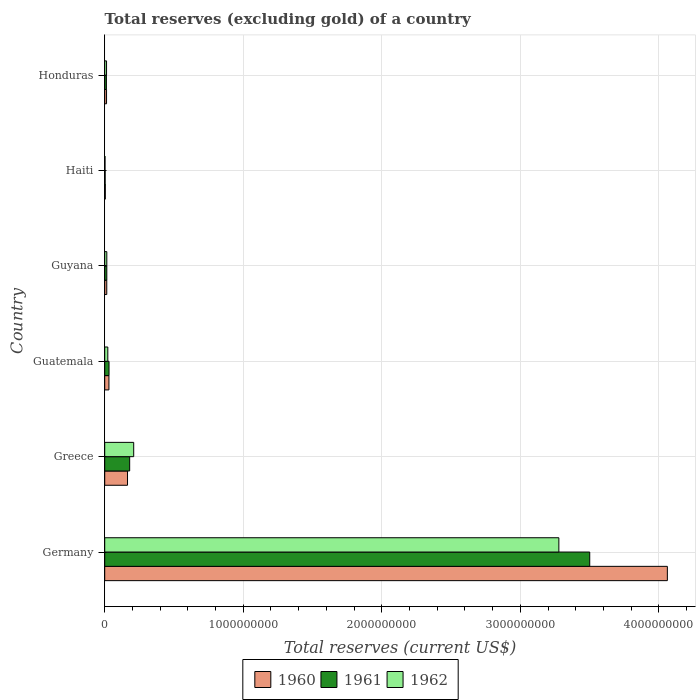How many bars are there on the 1st tick from the top?
Offer a terse response. 3. What is the label of the 2nd group of bars from the top?
Ensure brevity in your answer.  Haiti. What is the total reserves (excluding gold) in 1962 in Haiti?
Provide a succinct answer. 2.20e+06. Across all countries, what is the maximum total reserves (excluding gold) in 1962?
Offer a very short reply. 3.28e+09. Across all countries, what is the minimum total reserves (excluding gold) in 1962?
Provide a short and direct response. 2.20e+06. In which country was the total reserves (excluding gold) in 1961 maximum?
Make the answer very short. Germany. In which country was the total reserves (excluding gold) in 1962 minimum?
Your response must be concise. Haiti. What is the total total reserves (excluding gold) in 1961 in the graph?
Provide a short and direct response. 3.74e+09. What is the difference between the total reserves (excluding gold) in 1962 in Haiti and that in Honduras?
Provide a succinct answer. -1.10e+07. What is the difference between the total reserves (excluding gold) in 1960 in Guyana and the total reserves (excluding gold) in 1961 in Honduras?
Your response must be concise. 2.52e+06. What is the average total reserves (excluding gold) in 1960 per country?
Make the answer very short. 7.15e+08. What is the difference between the total reserves (excluding gold) in 1961 and total reserves (excluding gold) in 1960 in Honduras?
Make the answer very short. -9.90e+05. What is the ratio of the total reserves (excluding gold) in 1961 in Greece to that in Guyana?
Your answer should be very brief. 11.94. Is the total reserves (excluding gold) in 1961 in Germany less than that in Guatemala?
Provide a short and direct response. No. What is the difference between the highest and the second highest total reserves (excluding gold) in 1960?
Provide a succinct answer. 3.90e+09. What is the difference between the highest and the lowest total reserves (excluding gold) in 1961?
Make the answer very short. 3.50e+09. In how many countries, is the total reserves (excluding gold) in 1960 greater than the average total reserves (excluding gold) in 1960 taken over all countries?
Give a very brief answer. 1. What does the 1st bar from the top in Greece represents?
Provide a succinct answer. 1962. What does the 1st bar from the bottom in Greece represents?
Provide a short and direct response. 1960. Are all the bars in the graph horizontal?
Your answer should be very brief. Yes. What is the difference between two consecutive major ticks on the X-axis?
Offer a terse response. 1.00e+09. Are the values on the major ticks of X-axis written in scientific E-notation?
Provide a succinct answer. No. Does the graph contain grids?
Offer a terse response. Yes. Where does the legend appear in the graph?
Provide a short and direct response. Bottom center. How many legend labels are there?
Provide a short and direct response. 3. What is the title of the graph?
Provide a succinct answer. Total reserves (excluding gold) of a country. What is the label or title of the X-axis?
Offer a very short reply. Total reserves (current US$). What is the Total reserves (current US$) of 1960 in Germany?
Your answer should be compact. 4.06e+09. What is the Total reserves (current US$) in 1961 in Germany?
Offer a very short reply. 3.50e+09. What is the Total reserves (current US$) of 1962 in Germany?
Offer a terse response. 3.28e+09. What is the Total reserves (current US$) of 1960 in Greece?
Make the answer very short. 1.65e+08. What is the Total reserves (current US$) of 1961 in Greece?
Offer a terse response. 1.80e+08. What is the Total reserves (current US$) of 1962 in Greece?
Provide a succinct answer. 2.09e+08. What is the Total reserves (current US$) in 1960 in Guatemala?
Provide a short and direct response. 3.05e+07. What is the Total reserves (current US$) of 1961 in Guatemala?
Offer a terse response. 3.12e+07. What is the Total reserves (current US$) in 1962 in Guatemala?
Make the answer very short. 2.23e+07. What is the Total reserves (current US$) of 1960 in Guyana?
Offer a terse response. 1.47e+07. What is the Total reserves (current US$) in 1961 in Guyana?
Your answer should be very brief. 1.51e+07. What is the Total reserves (current US$) of 1962 in Guyana?
Provide a succinct answer. 1.51e+07. What is the Total reserves (current US$) of 1960 in Haiti?
Your answer should be compact. 4.30e+06. What is the Total reserves (current US$) of 1962 in Haiti?
Your answer should be compact. 2.20e+06. What is the Total reserves (current US$) in 1960 in Honduras?
Make the answer very short. 1.32e+07. What is the Total reserves (current US$) of 1961 in Honduras?
Offer a terse response. 1.22e+07. What is the Total reserves (current US$) in 1962 in Honduras?
Offer a terse response. 1.32e+07. Across all countries, what is the maximum Total reserves (current US$) of 1960?
Your answer should be compact. 4.06e+09. Across all countries, what is the maximum Total reserves (current US$) of 1961?
Make the answer very short. 3.50e+09. Across all countries, what is the maximum Total reserves (current US$) in 1962?
Keep it short and to the point. 3.28e+09. Across all countries, what is the minimum Total reserves (current US$) of 1960?
Give a very brief answer. 4.30e+06. Across all countries, what is the minimum Total reserves (current US$) of 1961?
Provide a short and direct response. 3.00e+06. Across all countries, what is the minimum Total reserves (current US$) in 1962?
Offer a terse response. 2.20e+06. What is the total Total reserves (current US$) in 1960 in the graph?
Make the answer very short. 4.29e+09. What is the total Total reserves (current US$) in 1961 in the graph?
Make the answer very short. 3.74e+09. What is the total Total reserves (current US$) of 1962 in the graph?
Make the answer very short. 3.54e+09. What is the difference between the Total reserves (current US$) of 1960 in Germany and that in Greece?
Your answer should be compact. 3.90e+09. What is the difference between the Total reserves (current US$) of 1961 in Germany and that in Greece?
Make the answer very short. 3.32e+09. What is the difference between the Total reserves (current US$) of 1962 in Germany and that in Greece?
Provide a succinct answer. 3.07e+09. What is the difference between the Total reserves (current US$) in 1960 in Germany and that in Guatemala?
Ensure brevity in your answer.  4.03e+09. What is the difference between the Total reserves (current US$) of 1961 in Germany and that in Guatemala?
Offer a very short reply. 3.47e+09. What is the difference between the Total reserves (current US$) in 1962 in Germany and that in Guatemala?
Make the answer very short. 3.26e+09. What is the difference between the Total reserves (current US$) in 1960 in Germany and that in Guyana?
Provide a short and direct response. 4.05e+09. What is the difference between the Total reserves (current US$) in 1961 in Germany and that in Guyana?
Your answer should be very brief. 3.49e+09. What is the difference between the Total reserves (current US$) of 1962 in Germany and that in Guyana?
Your answer should be compact. 3.26e+09. What is the difference between the Total reserves (current US$) of 1960 in Germany and that in Haiti?
Ensure brevity in your answer.  4.06e+09. What is the difference between the Total reserves (current US$) of 1961 in Germany and that in Haiti?
Your answer should be very brief. 3.50e+09. What is the difference between the Total reserves (current US$) of 1962 in Germany and that in Haiti?
Provide a short and direct response. 3.28e+09. What is the difference between the Total reserves (current US$) of 1960 in Germany and that in Honduras?
Your answer should be compact. 4.05e+09. What is the difference between the Total reserves (current US$) of 1961 in Germany and that in Honduras?
Your answer should be very brief. 3.49e+09. What is the difference between the Total reserves (current US$) in 1962 in Germany and that in Honduras?
Keep it short and to the point. 3.27e+09. What is the difference between the Total reserves (current US$) of 1960 in Greece and that in Guatemala?
Make the answer very short. 1.34e+08. What is the difference between the Total reserves (current US$) of 1961 in Greece and that in Guatemala?
Offer a very short reply. 1.49e+08. What is the difference between the Total reserves (current US$) in 1962 in Greece and that in Guatemala?
Provide a succinct answer. 1.87e+08. What is the difference between the Total reserves (current US$) of 1960 in Greece and that in Guyana?
Your answer should be compact. 1.50e+08. What is the difference between the Total reserves (current US$) of 1961 in Greece and that in Guyana?
Make the answer very short. 1.65e+08. What is the difference between the Total reserves (current US$) of 1962 in Greece and that in Guyana?
Provide a succinct answer. 1.94e+08. What is the difference between the Total reserves (current US$) in 1960 in Greece and that in Haiti?
Keep it short and to the point. 1.60e+08. What is the difference between the Total reserves (current US$) in 1961 in Greece and that in Haiti?
Ensure brevity in your answer.  1.77e+08. What is the difference between the Total reserves (current US$) of 1962 in Greece and that in Haiti?
Ensure brevity in your answer.  2.07e+08. What is the difference between the Total reserves (current US$) in 1960 in Greece and that in Honduras?
Offer a terse response. 1.51e+08. What is the difference between the Total reserves (current US$) of 1961 in Greece and that in Honduras?
Provide a short and direct response. 1.68e+08. What is the difference between the Total reserves (current US$) in 1962 in Greece and that in Honduras?
Your response must be concise. 1.96e+08. What is the difference between the Total reserves (current US$) in 1960 in Guatemala and that in Guyana?
Make the answer very short. 1.57e+07. What is the difference between the Total reserves (current US$) in 1961 in Guatemala and that in Guyana?
Offer a terse response. 1.61e+07. What is the difference between the Total reserves (current US$) of 1962 in Guatemala and that in Guyana?
Your response must be concise. 7.21e+06. What is the difference between the Total reserves (current US$) of 1960 in Guatemala and that in Haiti?
Ensure brevity in your answer.  2.62e+07. What is the difference between the Total reserves (current US$) of 1961 in Guatemala and that in Haiti?
Ensure brevity in your answer.  2.82e+07. What is the difference between the Total reserves (current US$) in 1962 in Guatemala and that in Haiti?
Ensure brevity in your answer.  2.01e+07. What is the difference between the Total reserves (current US$) in 1960 in Guatemala and that in Honduras?
Your answer should be compact. 1.72e+07. What is the difference between the Total reserves (current US$) of 1961 in Guatemala and that in Honduras?
Make the answer very short. 1.89e+07. What is the difference between the Total reserves (current US$) in 1962 in Guatemala and that in Honduras?
Your answer should be compact. 9.11e+06. What is the difference between the Total reserves (current US$) in 1960 in Guyana and that in Haiti?
Make the answer very short. 1.04e+07. What is the difference between the Total reserves (current US$) of 1961 in Guyana and that in Haiti?
Provide a succinct answer. 1.21e+07. What is the difference between the Total reserves (current US$) of 1962 in Guyana and that in Haiti?
Ensure brevity in your answer.  1.29e+07. What is the difference between the Total reserves (current US$) in 1960 in Guyana and that in Honduras?
Provide a succinct answer. 1.53e+06. What is the difference between the Total reserves (current US$) of 1961 in Guyana and that in Honduras?
Provide a short and direct response. 2.87e+06. What is the difference between the Total reserves (current US$) of 1962 in Guyana and that in Honduras?
Keep it short and to the point. 1.90e+06. What is the difference between the Total reserves (current US$) of 1960 in Haiti and that in Honduras?
Your response must be concise. -8.91e+06. What is the difference between the Total reserves (current US$) in 1961 in Haiti and that in Honduras?
Provide a succinct answer. -9.22e+06. What is the difference between the Total reserves (current US$) of 1962 in Haiti and that in Honduras?
Offer a very short reply. -1.10e+07. What is the difference between the Total reserves (current US$) of 1960 in Germany and the Total reserves (current US$) of 1961 in Greece?
Provide a short and direct response. 3.88e+09. What is the difference between the Total reserves (current US$) in 1960 in Germany and the Total reserves (current US$) in 1962 in Greece?
Your answer should be very brief. 3.85e+09. What is the difference between the Total reserves (current US$) of 1961 in Germany and the Total reserves (current US$) of 1962 in Greece?
Ensure brevity in your answer.  3.29e+09. What is the difference between the Total reserves (current US$) in 1960 in Germany and the Total reserves (current US$) in 1961 in Guatemala?
Provide a short and direct response. 4.03e+09. What is the difference between the Total reserves (current US$) of 1960 in Germany and the Total reserves (current US$) of 1962 in Guatemala?
Your answer should be very brief. 4.04e+09. What is the difference between the Total reserves (current US$) in 1961 in Germany and the Total reserves (current US$) in 1962 in Guatemala?
Your response must be concise. 3.48e+09. What is the difference between the Total reserves (current US$) in 1960 in Germany and the Total reserves (current US$) in 1961 in Guyana?
Keep it short and to the point. 4.05e+09. What is the difference between the Total reserves (current US$) in 1960 in Germany and the Total reserves (current US$) in 1962 in Guyana?
Ensure brevity in your answer.  4.05e+09. What is the difference between the Total reserves (current US$) of 1961 in Germany and the Total reserves (current US$) of 1962 in Guyana?
Your answer should be compact. 3.49e+09. What is the difference between the Total reserves (current US$) of 1960 in Germany and the Total reserves (current US$) of 1961 in Haiti?
Give a very brief answer. 4.06e+09. What is the difference between the Total reserves (current US$) of 1960 in Germany and the Total reserves (current US$) of 1962 in Haiti?
Provide a short and direct response. 4.06e+09. What is the difference between the Total reserves (current US$) in 1961 in Germany and the Total reserves (current US$) in 1962 in Haiti?
Give a very brief answer. 3.50e+09. What is the difference between the Total reserves (current US$) in 1960 in Germany and the Total reserves (current US$) in 1961 in Honduras?
Make the answer very short. 4.05e+09. What is the difference between the Total reserves (current US$) in 1960 in Germany and the Total reserves (current US$) in 1962 in Honduras?
Provide a short and direct response. 4.05e+09. What is the difference between the Total reserves (current US$) in 1961 in Germany and the Total reserves (current US$) in 1962 in Honduras?
Give a very brief answer. 3.49e+09. What is the difference between the Total reserves (current US$) in 1960 in Greece and the Total reserves (current US$) in 1961 in Guatemala?
Give a very brief answer. 1.33e+08. What is the difference between the Total reserves (current US$) in 1960 in Greece and the Total reserves (current US$) in 1962 in Guatemala?
Provide a succinct answer. 1.42e+08. What is the difference between the Total reserves (current US$) in 1961 in Greece and the Total reserves (current US$) in 1962 in Guatemala?
Offer a very short reply. 1.58e+08. What is the difference between the Total reserves (current US$) in 1960 in Greece and the Total reserves (current US$) in 1961 in Guyana?
Your answer should be compact. 1.50e+08. What is the difference between the Total reserves (current US$) of 1960 in Greece and the Total reserves (current US$) of 1962 in Guyana?
Provide a succinct answer. 1.50e+08. What is the difference between the Total reserves (current US$) of 1961 in Greece and the Total reserves (current US$) of 1962 in Guyana?
Give a very brief answer. 1.65e+08. What is the difference between the Total reserves (current US$) of 1960 in Greece and the Total reserves (current US$) of 1961 in Haiti?
Offer a terse response. 1.62e+08. What is the difference between the Total reserves (current US$) in 1960 in Greece and the Total reserves (current US$) in 1962 in Haiti?
Keep it short and to the point. 1.62e+08. What is the difference between the Total reserves (current US$) in 1961 in Greece and the Total reserves (current US$) in 1962 in Haiti?
Ensure brevity in your answer.  1.78e+08. What is the difference between the Total reserves (current US$) of 1960 in Greece and the Total reserves (current US$) of 1961 in Honduras?
Provide a succinct answer. 1.52e+08. What is the difference between the Total reserves (current US$) of 1960 in Greece and the Total reserves (current US$) of 1962 in Honduras?
Your answer should be very brief. 1.51e+08. What is the difference between the Total reserves (current US$) of 1961 in Greece and the Total reserves (current US$) of 1962 in Honduras?
Give a very brief answer. 1.67e+08. What is the difference between the Total reserves (current US$) in 1960 in Guatemala and the Total reserves (current US$) in 1961 in Guyana?
Provide a short and direct response. 1.54e+07. What is the difference between the Total reserves (current US$) of 1960 in Guatemala and the Total reserves (current US$) of 1962 in Guyana?
Make the answer very short. 1.54e+07. What is the difference between the Total reserves (current US$) of 1961 in Guatemala and the Total reserves (current US$) of 1962 in Guyana?
Make the answer very short. 1.61e+07. What is the difference between the Total reserves (current US$) of 1960 in Guatemala and the Total reserves (current US$) of 1961 in Haiti?
Your answer should be very brief. 2.75e+07. What is the difference between the Total reserves (current US$) in 1960 in Guatemala and the Total reserves (current US$) in 1962 in Haiti?
Give a very brief answer. 2.83e+07. What is the difference between the Total reserves (current US$) of 1961 in Guatemala and the Total reserves (current US$) of 1962 in Haiti?
Give a very brief answer. 2.90e+07. What is the difference between the Total reserves (current US$) of 1960 in Guatemala and the Total reserves (current US$) of 1961 in Honduras?
Provide a short and direct response. 1.82e+07. What is the difference between the Total reserves (current US$) in 1960 in Guatemala and the Total reserves (current US$) in 1962 in Honduras?
Provide a succinct answer. 1.73e+07. What is the difference between the Total reserves (current US$) in 1961 in Guatemala and the Total reserves (current US$) in 1962 in Honduras?
Your answer should be very brief. 1.80e+07. What is the difference between the Total reserves (current US$) of 1960 in Guyana and the Total reserves (current US$) of 1961 in Haiti?
Make the answer very short. 1.17e+07. What is the difference between the Total reserves (current US$) in 1960 in Guyana and the Total reserves (current US$) in 1962 in Haiti?
Ensure brevity in your answer.  1.25e+07. What is the difference between the Total reserves (current US$) in 1961 in Guyana and the Total reserves (current US$) in 1962 in Haiti?
Offer a terse response. 1.29e+07. What is the difference between the Total reserves (current US$) of 1960 in Guyana and the Total reserves (current US$) of 1961 in Honduras?
Provide a succinct answer. 2.52e+06. What is the difference between the Total reserves (current US$) of 1960 in Guyana and the Total reserves (current US$) of 1962 in Honduras?
Provide a short and direct response. 1.55e+06. What is the difference between the Total reserves (current US$) in 1961 in Guyana and the Total reserves (current US$) in 1962 in Honduras?
Provide a succinct answer. 1.90e+06. What is the difference between the Total reserves (current US$) in 1960 in Haiti and the Total reserves (current US$) in 1961 in Honduras?
Keep it short and to the point. -7.92e+06. What is the difference between the Total reserves (current US$) in 1960 in Haiti and the Total reserves (current US$) in 1962 in Honduras?
Offer a very short reply. -8.89e+06. What is the difference between the Total reserves (current US$) in 1961 in Haiti and the Total reserves (current US$) in 1962 in Honduras?
Provide a succinct answer. -1.02e+07. What is the average Total reserves (current US$) in 1960 per country?
Your answer should be very brief. 7.15e+08. What is the average Total reserves (current US$) of 1961 per country?
Offer a very short reply. 6.24e+08. What is the average Total reserves (current US$) in 1962 per country?
Offer a very short reply. 5.90e+08. What is the difference between the Total reserves (current US$) of 1960 and Total reserves (current US$) of 1961 in Germany?
Make the answer very short. 5.60e+08. What is the difference between the Total reserves (current US$) in 1960 and Total reserves (current US$) in 1962 in Germany?
Keep it short and to the point. 7.83e+08. What is the difference between the Total reserves (current US$) of 1961 and Total reserves (current US$) of 1962 in Germany?
Your answer should be very brief. 2.23e+08. What is the difference between the Total reserves (current US$) in 1960 and Total reserves (current US$) in 1961 in Greece?
Ensure brevity in your answer.  -1.55e+07. What is the difference between the Total reserves (current US$) of 1960 and Total reserves (current US$) of 1962 in Greece?
Make the answer very short. -4.46e+07. What is the difference between the Total reserves (current US$) of 1961 and Total reserves (current US$) of 1962 in Greece?
Make the answer very short. -2.91e+07. What is the difference between the Total reserves (current US$) in 1960 and Total reserves (current US$) in 1961 in Guatemala?
Ensure brevity in your answer.  -7.00e+05. What is the difference between the Total reserves (current US$) of 1960 and Total reserves (current US$) of 1962 in Guatemala?
Ensure brevity in your answer.  8.16e+06. What is the difference between the Total reserves (current US$) in 1961 and Total reserves (current US$) in 1962 in Guatemala?
Provide a succinct answer. 8.86e+06. What is the difference between the Total reserves (current US$) of 1960 and Total reserves (current US$) of 1961 in Guyana?
Ensure brevity in your answer.  -3.50e+05. What is the difference between the Total reserves (current US$) of 1960 and Total reserves (current US$) of 1962 in Guyana?
Your answer should be very brief. -3.50e+05. What is the difference between the Total reserves (current US$) of 1960 and Total reserves (current US$) of 1961 in Haiti?
Keep it short and to the point. 1.30e+06. What is the difference between the Total reserves (current US$) of 1960 and Total reserves (current US$) of 1962 in Haiti?
Provide a short and direct response. 2.10e+06. What is the difference between the Total reserves (current US$) in 1961 and Total reserves (current US$) in 1962 in Haiti?
Make the answer very short. 8.00e+05. What is the difference between the Total reserves (current US$) in 1960 and Total reserves (current US$) in 1961 in Honduras?
Offer a terse response. 9.90e+05. What is the difference between the Total reserves (current US$) of 1960 and Total reserves (current US$) of 1962 in Honduras?
Make the answer very short. 2.00e+04. What is the difference between the Total reserves (current US$) in 1961 and Total reserves (current US$) in 1962 in Honduras?
Ensure brevity in your answer.  -9.70e+05. What is the ratio of the Total reserves (current US$) in 1960 in Germany to that in Greece?
Give a very brief answer. 24.68. What is the ratio of the Total reserves (current US$) of 1961 in Germany to that in Greece?
Your answer should be very brief. 19.44. What is the ratio of the Total reserves (current US$) in 1962 in Germany to that in Greece?
Ensure brevity in your answer.  15.67. What is the ratio of the Total reserves (current US$) in 1960 in Germany to that in Guatemala?
Make the answer very short. 133.34. What is the ratio of the Total reserves (current US$) in 1961 in Germany to that in Guatemala?
Your answer should be very brief. 112.36. What is the ratio of the Total reserves (current US$) of 1962 in Germany to that in Guatemala?
Your answer should be very brief. 147.01. What is the ratio of the Total reserves (current US$) in 1960 in Germany to that in Guyana?
Keep it short and to the point. 275.55. What is the ratio of the Total reserves (current US$) of 1961 in Germany to that in Guyana?
Your response must be concise. 232.03. What is the ratio of the Total reserves (current US$) in 1962 in Germany to that in Guyana?
Your answer should be very brief. 217.26. What is the ratio of the Total reserves (current US$) in 1960 in Germany to that in Haiti?
Your response must be concise. 944.57. What is the ratio of the Total reserves (current US$) of 1961 in Germany to that in Haiti?
Your answer should be compact. 1167.09. What is the ratio of the Total reserves (current US$) of 1962 in Germany to that in Haiti?
Offer a very short reply. 1490.2. What is the ratio of the Total reserves (current US$) in 1960 in Germany to that in Honduras?
Your answer should be very brief. 307.47. What is the ratio of the Total reserves (current US$) of 1961 in Germany to that in Honduras?
Make the answer very short. 286.52. What is the ratio of the Total reserves (current US$) of 1962 in Germany to that in Honduras?
Offer a very short reply. 248.55. What is the ratio of the Total reserves (current US$) in 1960 in Greece to that in Guatemala?
Your answer should be compact. 5.4. What is the ratio of the Total reserves (current US$) of 1961 in Greece to that in Guatemala?
Your response must be concise. 5.78. What is the ratio of the Total reserves (current US$) of 1962 in Greece to that in Guatemala?
Your answer should be very brief. 9.38. What is the ratio of the Total reserves (current US$) of 1960 in Greece to that in Guyana?
Ensure brevity in your answer.  11.17. What is the ratio of the Total reserves (current US$) of 1961 in Greece to that in Guyana?
Your answer should be compact. 11.94. What is the ratio of the Total reserves (current US$) in 1962 in Greece to that in Guyana?
Your response must be concise. 13.86. What is the ratio of the Total reserves (current US$) of 1960 in Greece to that in Haiti?
Give a very brief answer. 38.28. What is the ratio of the Total reserves (current US$) of 1961 in Greece to that in Haiti?
Your response must be concise. 60.03. What is the ratio of the Total reserves (current US$) in 1962 in Greece to that in Haiti?
Make the answer very short. 95.09. What is the ratio of the Total reserves (current US$) of 1960 in Greece to that in Honduras?
Give a very brief answer. 12.46. What is the ratio of the Total reserves (current US$) of 1961 in Greece to that in Honduras?
Your answer should be very brief. 14.74. What is the ratio of the Total reserves (current US$) in 1962 in Greece to that in Honduras?
Ensure brevity in your answer.  15.86. What is the ratio of the Total reserves (current US$) in 1960 in Guatemala to that in Guyana?
Give a very brief answer. 2.07. What is the ratio of the Total reserves (current US$) in 1961 in Guatemala to that in Guyana?
Ensure brevity in your answer.  2.06. What is the ratio of the Total reserves (current US$) of 1962 in Guatemala to that in Guyana?
Your response must be concise. 1.48. What is the ratio of the Total reserves (current US$) in 1960 in Guatemala to that in Haiti?
Offer a very short reply. 7.08. What is the ratio of the Total reserves (current US$) of 1961 in Guatemala to that in Haiti?
Offer a terse response. 10.39. What is the ratio of the Total reserves (current US$) in 1962 in Guatemala to that in Haiti?
Ensure brevity in your answer.  10.14. What is the ratio of the Total reserves (current US$) of 1960 in Guatemala to that in Honduras?
Give a very brief answer. 2.31. What is the ratio of the Total reserves (current US$) in 1961 in Guatemala to that in Honduras?
Offer a very short reply. 2.55. What is the ratio of the Total reserves (current US$) in 1962 in Guatemala to that in Honduras?
Keep it short and to the point. 1.69. What is the ratio of the Total reserves (current US$) of 1960 in Guyana to that in Haiti?
Give a very brief answer. 3.43. What is the ratio of the Total reserves (current US$) in 1961 in Guyana to that in Haiti?
Offer a terse response. 5.03. What is the ratio of the Total reserves (current US$) of 1962 in Guyana to that in Haiti?
Keep it short and to the point. 6.86. What is the ratio of the Total reserves (current US$) of 1960 in Guyana to that in Honduras?
Your answer should be very brief. 1.12. What is the ratio of the Total reserves (current US$) of 1961 in Guyana to that in Honduras?
Your answer should be very brief. 1.23. What is the ratio of the Total reserves (current US$) of 1962 in Guyana to that in Honduras?
Offer a terse response. 1.14. What is the ratio of the Total reserves (current US$) of 1960 in Haiti to that in Honduras?
Your answer should be compact. 0.33. What is the ratio of the Total reserves (current US$) in 1961 in Haiti to that in Honduras?
Offer a terse response. 0.25. What is the ratio of the Total reserves (current US$) in 1962 in Haiti to that in Honduras?
Provide a succinct answer. 0.17. What is the difference between the highest and the second highest Total reserves (current US$) of 1960?
Ensure brevity in your answer.  3.90e+09. What is the difference between the highest and the second highest Total reserves (current US$) in 1961?
Your answer should be very brief. 3.32e+09. What is the difference between the highest and the second highest Total reserves (current US$) of 1962?
Ensure brevity in your answer.  3.07e+09. What is the difference between the highest and the lowest Total reserves (current US$) in 1960?
Your response must be concise. 4.06e+09. What is the difference between the highest and the lowest Total reserves (current US$) of 1961?
Your answer should be compact. 3.50e+09. What is the difference between the highest and the lowest Total reserves (current US$) in 1962?
Your answer should be very brief. 3.28e+09. 